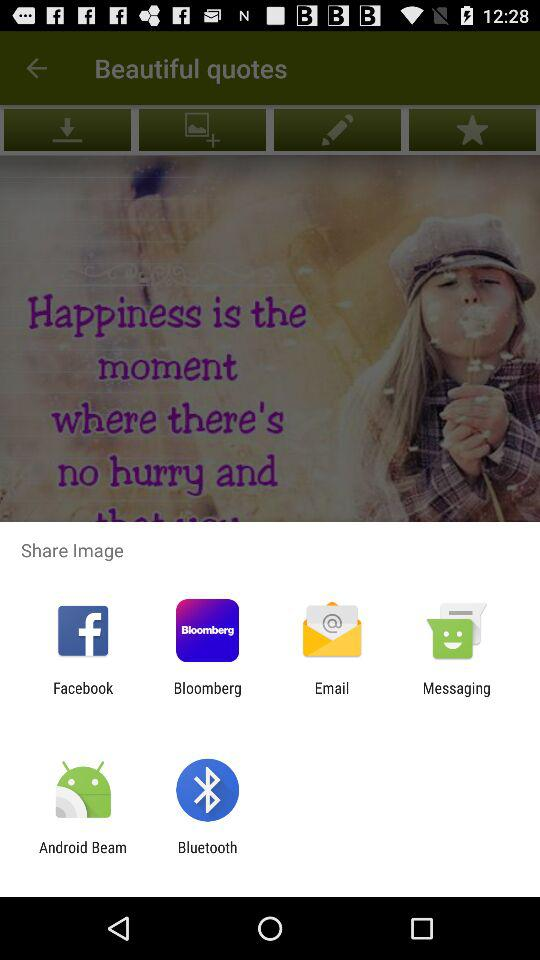Through which app can I share an image? You can share it with "Facebook", "Bloomberg", "Email", "Messaging", "Android Beam" and "Bluetooth". 